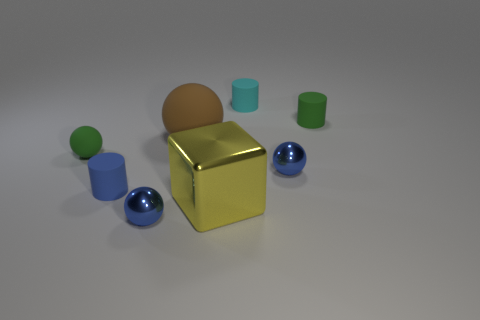Which objects could feasibly be used together based on their shapes? The cylindrical objects have similar shapes that could allow them to be stacked or placed side by side in a functional grouping. Imagine a scenario where these objects could be used. What purpose would they serve? Given their varied shapes and sizes, these objects could be part of a children's toy set, used for educational purposes such as teaching about shapes, sizes, and colors, or even as building elements for a game of creativity and balance. 